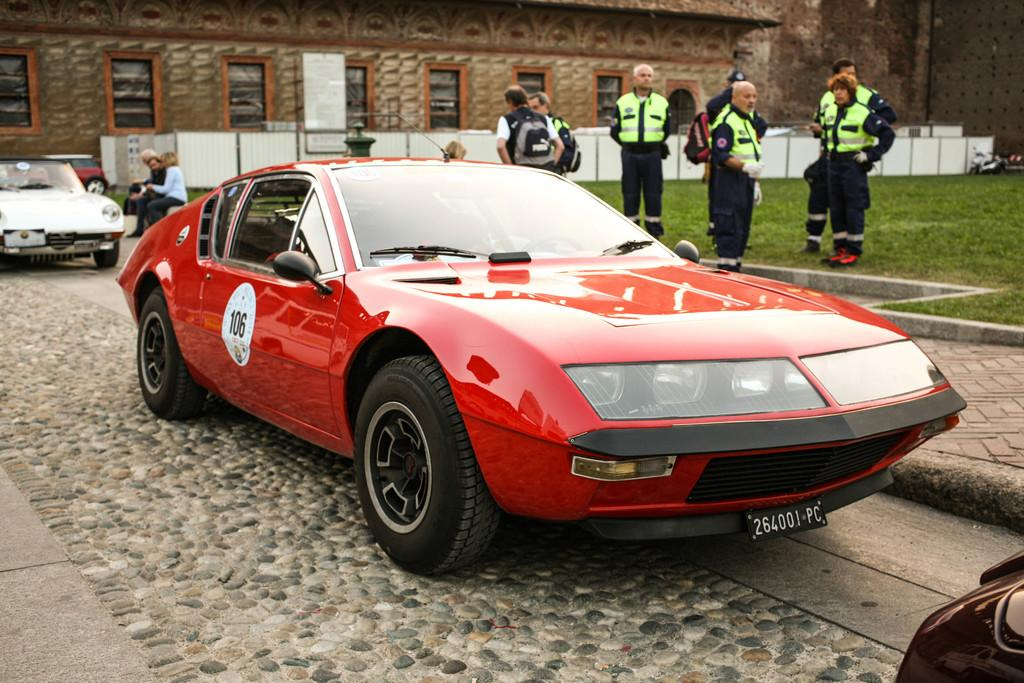What types of objects can be seen in the image? There are vehicles in the image. What else can be seen in the image besides the vehicles? There is a group of people on the ground, grass, a fence, and a building with windows in the image. What type of joke is being told by the society in the image? There is no indication of a joke or society present in the image; it features vehicles, a group of people, grass, a fence, and a building with windows. Is there any snow visible in the image? No, there is no snow present in the image; it features vehicles, a group of people, grass, a fence, and a building with windows. 